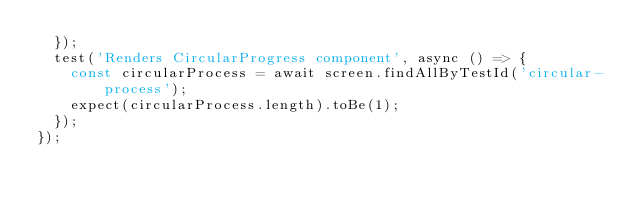<code> <loc_0><loc_0><loc_500><loc_500><_JavaScript_>  });
  test('Renders CircularProgress component', async () => {
    const circularProcess = await screen.findAllByTestId('circular-process');
    expect(circularProcess.length).toBe(1);
  });
});
</code> 